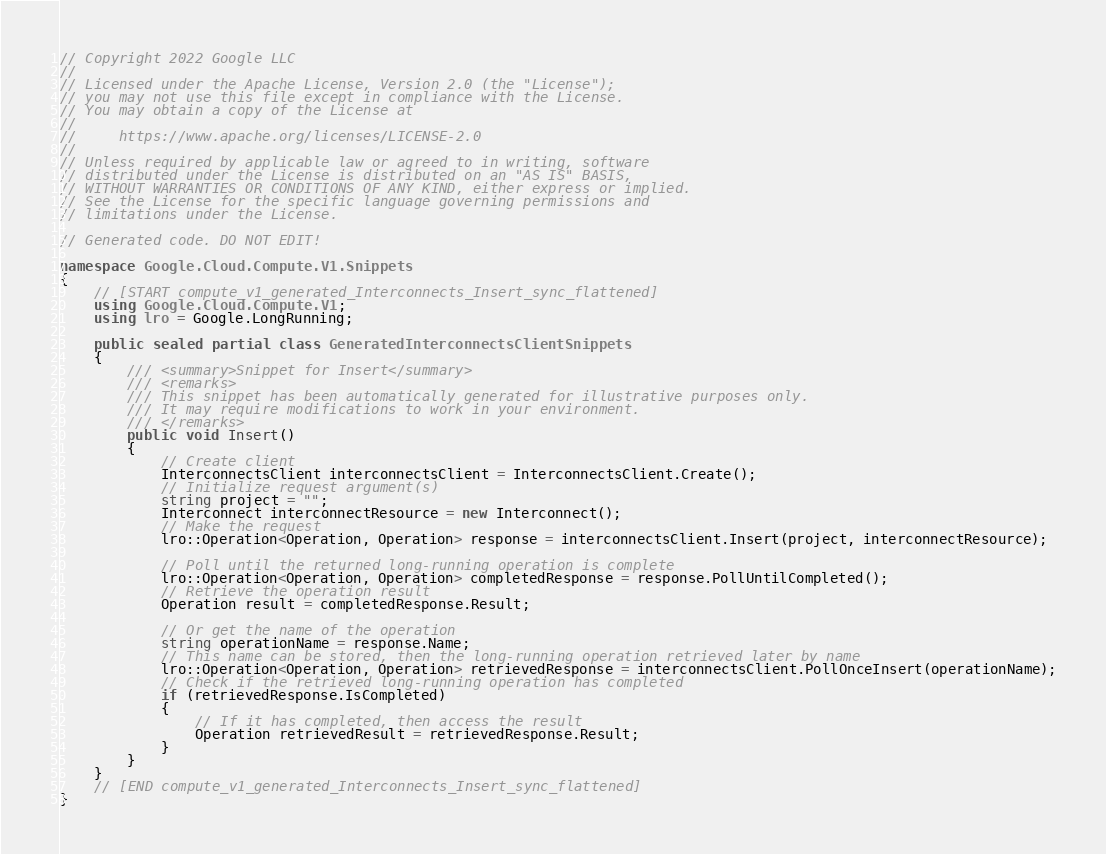<code> <loc_0><loc_0><loc_500><loc_500><_C#_>// Copyright 2022 Google LLC
//
// Licensed under the Apache License, Version 2.0 (the "License");
// you may not use this file except in compliance with the License.
// You may obtain a copy of the License at
//
//     https://www.apache.org/licenses/LICENSE-2.0
//
// Unless required by applicable law or agreed to in writing, software
// distributed under the License is distributed on an "AS IS" BASIS,
// WITHOUT WARRANTIES OR CONDITIONS OF ANY KIND, either express or implied.
// See the License for the specific language governing permissions and
// limitations under the License.

// Generated code. DO NOT EDIT!

namespace Google.Cloud.Compute.V1.Snippets
{
    // [START compute_v1_generated_Interconnects_Insert_sync_flattened]
    using Google.Cloud.Compute.V1;
    using lro = Google.LongRunning;

    public sealed partial class GeneratedInterconnectsClientSnippets
    {
        /// <summary>Snippet for Insert</summary>
        /// <remarks>
        /// This snippet has been automatically generated for illustrative purposes only.
        /// It may require modifications to work in your environment.
        /// </remarks>
        public void Insert()
        {
            // Create client
            InterconnectsClient interconnectsClient = InterconnectsClient.Create();
            // Initialize request argument(s)
            string project = "";
            Interconnect interconnectResource = new Interconnect();
            // Make the request
            lro::Operation<Operation, Operation> response = interconnectsClient.Insert(project, interconnectResource);

            // Poll until the returned long-running operation is complete
            lro::Operation<Operation, Operation> completedResponse = response.PollUntilCompleted();
            // Retrieve the operation result
            Operation result = completedResponse.Result;

            // Or get the name of the operation
            string operationName = response.Name;
            // This name can be stored, then the long-running operation retrieved later by name
            lro::Operation<Operation, Operation> retrievedResponse = interconnectsClient.PollOnceInsert(operationName);
            // Check if the retrieved long-running operation has completed
            if (retrievedResponse.IsCompleted)
            {
                // If it has completed, then access the result
                Operation retrievedResult = retrievedResponse.Result;
            }
        }
    }
    // [END compute_v1_generated_Interconnects_Insert_sync_flattened]
}
</code> 